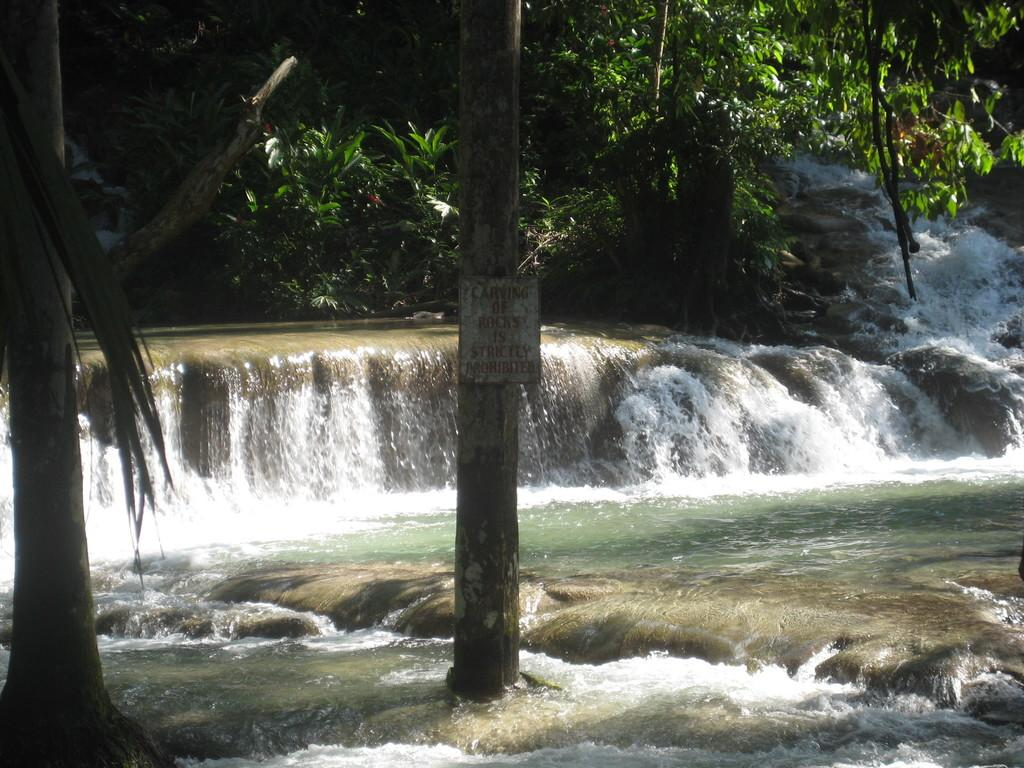What natural feature is the main subject of the image? There is a waterfall in the image. What type of vegetation is present in the image? There are many trees in the image. Can you describe any man-made structures in the image? There is a pole with a board on it in the image. How many dinosaurs can be seen near the waterfall in the image? There are no dinosaurs present in the image. Can you describe the height of the giraffe near the waterfall in the image? There is no giraffe present in the image. 